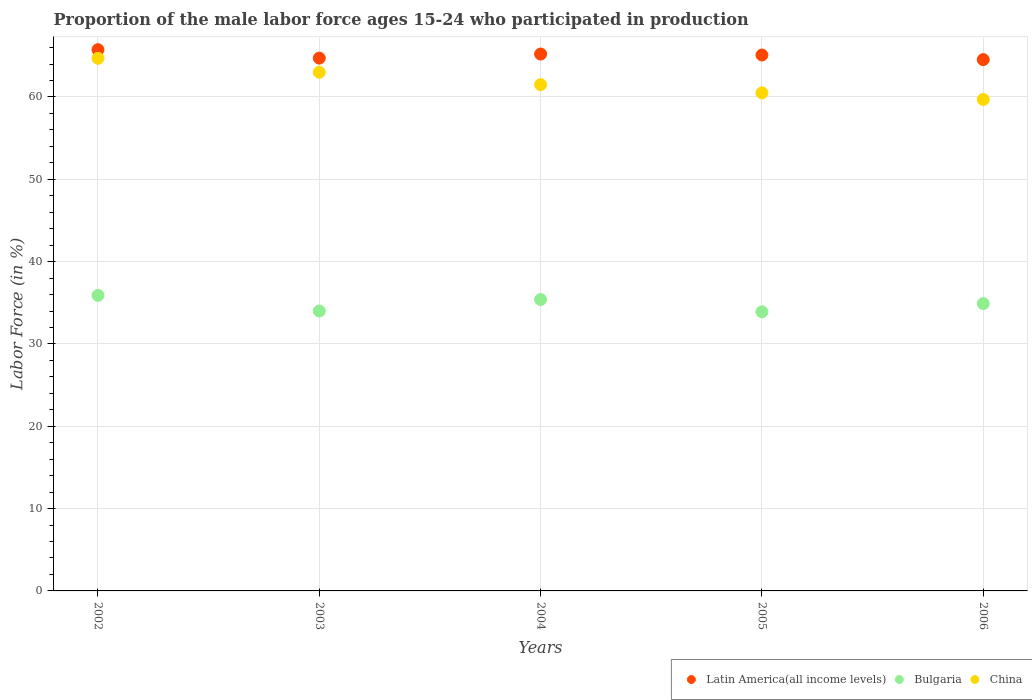What is the proportion of the male labor force who participated in production in Bulgaria in 2006?
Make the answer very short. 34.9. Across all years, what is the maximum proportion of the male labor force who participated in production in Latin America(all income levels)?
Keep it short and to the point. 65.75. Across all years, what is the minimum proportion of the male labor force who participated in production in China?
Offer a terse response. 59.7. What is the total proportion of the male labor force who participated in production in Latin America(all income levels) in the graph?
Keep it short and to the point. 325.32. What is the difference between the proportion of the male labor force who participated in production in Latin America(all income levels) in 2002 and that in 2004?
Give a very brief answer. 0.53. What is the difference between the proportion of the male labor force who participated in production in Latin America(all income levels) in 2006 and the proportion of the male labor force who participated in production in Bulgaria in 2002?
Provide a short and direct response. 28.64. What is the average proportion of the male labor force who participated in production in Latin America(all income levels) per year?
Ensure brevity in your answer.  65.06. In the year 2005, what is the difference between the proportion of the male labor force who participated in production in China and proportion of the male labor force who participated in production in Latin America(all income levels)?
Offer a very short reply. -4.6. In how many years, is the proportion of the male labor force who participated in production in Latin America(all income levels) greater than 38 %?
Give a very brief answer. 5. What is the ratio of the proportion of the male labor force who participated in production in China in 2005 to that in 2006?
Offer a very short reply. 1.01. Is the proportion of the male labor force who participated in production in Latin America(all income levels) in 2004 less than that in 2006?
Make the answer very short. No. Is the difference between the proportion of the male labor force who participated in production in China in 2004 and 2005 greater than the difference between the proportion of the male labor force who participated in production in Latin America(all income levels) in 2004 and 2005?
Your response must be concise. Yes. What is the difference between the highest and the second highest proportion of the male labor force who participated in production in China?
Offer a terse response. 1.7. What is the difference between the highest and the lowest proportion of the male labor force who participated in production in Latin America(all income levels)?
Give a very brief answer. 1.21. Does the proportion of the male labor force who participated in production in China monotonically increase over the years?
Your answer should be very brief. No. Is the proportion of the male labor force who participated in production in China strictly greater than the proportion of the male labor force who participated in production in Bulgaria over the years?
Provide a short and direct response. Yes. Is the proportion of the male labor force who participated in production in Bulgaria strictly less than the proportion of the male labor force who participated in production in China over the years?
Your answer should be compact. Yes. How many dotlines are there?
Make the answer very short. 3. Are the values on the major ticks of Y-axis written in scientific E-notation?
Offer a very short reply. No. Does the graph contain any zero values?
Keep it short and to the point. No. Does the graph contain grids?
Make the answer very short. Yes. Where does the legend appear in the graph?
Provide a short and direct response. Bottom right. How are the legend labels stacked?
Your answer should be compact. Horizontal. What is the title of the graph?
Ensure brevity in your answer.  Proportion of the male labor force ages 15-24 who participated in production. What is the label or title of the Y-axis?
Make the answer very short. Labor Force (in %). What is the Labor Force (in %) in Latin America(all income levels) in 2002?
Your response must be concise. 65.75. What is the Labor Force (in %) of Bulgaria in 2002?
Offer a very short reply. 35.9. What is the Labor Force (in %) of China in 2002?
Give a very brief answer. 64.7. What is the Labor Force (in %) in Latin America(all income levels) in 2003?
Give a very brief answer. 64.72. What is the Labor Force (in %) in Bulgaria in 2003?
Offer a very short reply. 34. What is the Labor Force (in %) in China in 2003?
Keep it short and to the point. 63. What is the Labor Force (in %) in Latin America(all income levels) in 2004?
Your response must be concise. 65.22. What is the Labor Force (in %) of Bulgaria in 2004?
Ensure brevity in your answer.  35.4. What is the Labor Force (in %) in China in 2004?
Ensure brevity in your answer.  61.5. What is the Labor Force (in %) in Latin America(all income levels) in 2005?
Provide a succinct answer. 65.1. What is the Labor Force (in %) of Bulgaria in 2005?
Offer a very short reply. 33.9. What is the Labor Force (in %) in China in 2005?
Your answer should be very brief. 60.5. What is the Labor Force (in %) of Latin America(all income levels) in 2006?
Your response must be concise. 64.54. What is the Labor Force (in %) in Bulgaria in 2006?
Your answer should be compact. 34.9. What is the Labor Force (in %) in China in 2006?
Your response must be concise. 59.7. Across all years, what is the maximum Labor Force (in %) in Latin America(all income levels)?
Make the answer very short. 65.75. Across all years, what is the maximum Labor Force (in %) in Bulgaria?
Your response must be concise. 35.9. Across all years, what is the maximum Labor Force (in %) in China?
Provide a succinct answer. 64.7. Across all years, what is the minimum Labor Force (in %) in Latin America(all income levels)?
Your answer should be compact. 64.54. Across all years, what is the minimum Labor Force (in %) in Bulgaria?
Your response must be concise. 33.9. Across all years, what is the minimum Labor Force (in %) of China?
Your response must be concise. 59.7. What is the total Labor Force (in %) of Latin America(all income levels) in the graph?
Offer a very short reply. 325.32. What is the total Labor Force (in %) in Bulgaria in the graph?
Offer a terse response. 174.1. What is the total Labor Force (in %) in China in the graph?
Make the answer very short. 309.4. What is the difference between the Labor Force (in %) in Latin America(all income levels) in 2002 and that in 2003?
Provide a succinct answer. 1.02. What is the difference between the Labor Force (in %) in Bulgaria in 2002 and that in 2003?
Your response must be concise. 1.9. What is the difference between the Labor Force (in %) in Latin America(all income levels) in 2002 and that in 2004?
Offer a very short reply. 0.53. What is the difference between the Labor Force (in %) of Bulgaria in 2002 and that in 2004?
Keep it short and to the point. 0.5. What is the difference between the Labor Force (in %) of China in 2002 and that in 2004?
Offer a very short reply. 3.2. What is the difference between the Labor Force (in %) of Latin America(all income levels) in 2002 and that in 2005?
Keep it short and to the point. 0.65. What is the difference between the Labor Force (in %) of Latin America(all income levels) in 2002 and that in 2006?
Your response must be concise. 1.21. What is the difference between the Labor Force (in %) in China in 2002 and that in 2006?
Ensure brevity in your answer.  5. What is the difference between the Labor Force (in %) of Latin America(all income levels) in 2003 and that in 2004?
Ensure brevity in your answer.  -0.49. What is the difference between the Labor Force (in %) in China in 2003 and that in 2004?
Ensure brevity in your answer.  1.5. What is the difference between the Labor Force (in %) in Latin America(all income levels) in 2003 and that in 2005?
Your answer should be compact. -0.38. What is the difference between the Labor Force (in %) in Latin America(all income levels) in 2003 and that in 2006?
Give a very brief answer. 0.18. What is the difference between the Labor Force (in %) in Latin America(all income levels) in 2004 and that in 2005?
Your answer should be very brief. 0.12. What is the difference between the Labor Force (in %) in China in 2004 and that in 2005?
Make the answer very short. 1. What is the difference between the Labor Force (in %) of Latin America(all income levels) in 2004 and that in 2006?
Give a very brief answer. 0.68. What is the difference between the Labor Force (in %) of Latin America(all income levels) in 2005 and that in 2006?
Provide a succinct answer. 0.56. What is the difference between the Labor Force (in %) of Bulgaria in 2005 and that in 2006?
Your answer should be compact. -1. What is the difference between the Labor Force (in %) of China in 2005 and that in 2006?
Give a very brief answer. 0.8. What is the difference between the Labor Force (in %) in Latin America(all income levels) in 2002 and the Labor Force (in %) in Bulgaria in 2003?
Your answer should be compact. 31.75. What is the difference between the Labor Force (in %) of Latin America(all income levels) in 2002 and the Labor Force (in %) of China in 2003?
Your answer should be very brief. 2.75. What is the difference between the Labor Force (in %) of Bulgaria in 2002 and the Labor Force (in %) of China in 2003?
Make the answer very short. -27.1. What is the difference between the Labor Force (in %) in Latin America(all income levels) in 2002 and the Labor Force (in %) in Bulgaria in 2004?
Offer a very short reply. 30.35. What is the difference between the Labor Force (in %) of Latin America(all income levels) in 2002 and the Labor Force (in %) of China in 2004?
Give a very brief answer. 4.25. What is the difference between the Labor Force (in %) of Bulgaria in 2002 and the Labor Force (in %) of China in 2004?
Offer a terse response. -25.6. What is the difference between the Labor Force (in %) of Latin America(all income levels) in 2002 and the Labor Force (in %) of Bulgaria in 2005?
Ensure brevity in your answer.  31.85. What is the difference between the Labor Force (in %) in Latin America(all income levels) in 2002 and the Labor Force (in %) in China in 2005?
Provide a short and direct response. 5.25. What is the difference between the Labor Force (in %) of Bulgaria in 2002 and the Labor Force (in %) of China in 2005?
Offer a terse response. -24.6. What is the difference between the Labor Force (in %) in Latin America(all income levels) in 2002 and the Labor Force (in %) in Bulgaria in 2006?
Make the answer very short. 30.85. What is the difference between the Labor Force (in %) in Latin America(all income levels) in 2002 and the Labor Force (in %) in China in 2006?
Offer a terse response. 6.05. What is the difference between the Labor Force (in %) in Bulgaria in 2002 and the Labor Force (in %) in China in 2006?
Keep it short and to the point. -23.8. What is the difference between the Labor Force (in %) in Latin America(all income levels) in 2003 and the Labor Force (in %) in Bulgaria in 2004?
Your answer should be very brief. 29.32. What is the difference between the Labor Force (in %) in Latin America(all income levels) in 2003 and the Labor Force (in %) in China in 2004?
Your answer should be compact. 3.22. What is the difference between the Labor Force (in %) of Bulgaria in 2003 and the Labor Force (in %) of China in 2004?
Your answer should be compact. -27.5. What is the difference between the Labor Force (in %) in Latin America(all income levels) in 2003 and the Labor Force (in %) in Bulgaria in 2005?
Offer a terse response. 30.82. What is the difference between the Labor Force (in %) in Latin America(all income levels) in 2003 and the Labor Force (in %) in China in 2005?
Provide a succinct answer. 4.22. What is the difference between the Labor Force (in %) of Bulgaria in 2003 and the Labor Force (in %) of China in 2005?
Your answer should be very brief. -26.5. What is the difference between the Labor Force (in %) of Latin America(all income levels) in 2003 and the Labor Force (in %) of Bulgaria in 2006?
Offer a very short reply. 29.82. What is the difference between the Labor Force (in %) in Latin America(all income levels) in 2003 and the Labor Force (in %) in China in 2006?
Your answer should be very brief. 5.02. What is the difference between the Labor Force (in %) of Bulgaria in 2003 and the Labor Force (in %) of China in 2006?
Keep it short and to the point. -25.7. What is the difference between the Labor Force (in %) in Latin America(all income levels) in 2004 and the Labor Force (in %) in Bulgaria in 2005?
Give a very brief answer. 31.32. What is the difference between the Labor Force (in %) of Latin America(all income levels) in 2004 and the Labor Force (in %) of China in 2005?
Your answer should be very brief. 4.72. What is the difference between the Labor Force (in %) of Bulgaria in 2004 and the Labor Force (in %) of China in 2005?
Make the answer very short. -25.1. What is the difference between the Labor Force (in %) of Latin America(all income levels) in 2004 and the Labor Force (in %) of Bulgaria in 2006?
Make the answer very short. 30.32. What is the difference between the Labor Force (in %) of Latin America(all income levels) in 2004 and the Labor Force (in %) of China in 2006?
Make the answer very short. 5.52. What is the difference between the Labor Force (in %) of Bulgaria in 2004 and the Labor Force (in %) of China in 2006?
Offer a very short reply. -24.3. What is the difference between the Labor Force (in %) in Latin America(all income levels) in 2005 and the Labor Force (in %) in Bulgaria in 2006?
Make the answer very short. 30.2. What is the difference between the Labor Force (in %) of Latin America(all income levels) in 2005 and the Labor Force (in %) of China in 2006?
Provide a short and direct response. 5.4. What is the difference between the Labor Force (in %) of Bulgaria in 2005 and the Labor Force (in %) of China in 2006?
Offer a terse response. -25.8. What is the average Labor Force (in %) in Latin America(all income levels) per year?
Ensure brevity in your answer.  65.06. What is the average Labor Force (in %) of Bulgaria per year?
Make the answer very short. 34.82. What is the average Labor Force (in %) in China per year?
Provide a succinct answer. 61.88. In the year 2002, what is the difference between the Labor Force (in %) of Latin America(all income levels) and Labor Force (in %) of Bulgaria?
Your answer should be compact. 29.85. In the year 2002, what is the difference between the Labor Force (in %) of Latin America(all income levels) and Labor Force (in %) of China?
Your answer should be very brief. 1.05. In the year 2002, what is the difference between the Labor Force (in %) of Bulgaria and Labor Force (in %) of China?
Provide a short and direct response. -28.8. In the year 2003, what is the difference between the Labor Force (in %) of Latin America(all income levels) and Labor Force (in %) of Bulgaria?
Provide a short and direct response. 30.72. In the year 2003, what is the difference between the Labor Force (in %) in Latin America(all income levels) and Labor Force (in %) in China?
Offer a terse response. 1.72. In the year 2003, what is the difference between the Labor Force (in %) in Bulgaria and Labor Force (in %) in China?
Your response must be concise. -29. In the year 2004, what is the difference between the Labor Force (in %) in Latin America(all income levels) and Labor Force (in %) in Bulgaria?
Ensure brevity in your answer.  29.82. In the year 2004, what is the difference between the Labor Force (in %) of Latin America(all income levels) and Labor Force (in %) of China?
Make the answer very short. 3.72. In the year 2004, what is the difference between the Labor Force (in %) in Bulgaria and Labor Force (in %) in China?
Make the answer very short. -26.1. In the year 2005, what is the difference between the Labor Force (in %) of Latin America(all income levels) and Labor Force (in %) of Bulgaria?
Keep it short and to the point. 31.2. In the year 2005, what is the difference between the Labor Force (in %) of Latin America(all income levels) and Labor Force (in %) of China?
Offer a very short reply. 4.6. In the year 2005, what is the difference between the Labor Force (in %) of Bulgaria and Labor Force (in %) of China?
Provide a short and direct response. -26.6. In the year 2006, what is the difference between the Labor Force (in %) of Latin America(all income levels) and Labor Force (in %) of Bulgaria?
Give a very brief answer. 29.64. In the year 2006, what is the difference between the Labor Force (in %) of Latin America(all income levels) and Labor Force (in %) of China?
Your answer should be compact. 4.84. In the year 2006, what is the difference between the Labor Force (in %) in Bulgaria and Labor Force (in %) in China?
Offer a very short reply. -24.8. What is the ratio of the Labor Force (in %) in Latin America(all income levels) in 2002 to that in 2003?
Your answer should be compact. 1.02. What is the ratio of the Labor Force (in %) of Bulgaria in 2002 to that in 2003?
Make the answer very short. 1.06. What is the ratio of the Labor Force (in %) in Latin America(all income levels) in 2002 to that in 2004?
Provide a succinct answer. 1.01. What is the ratio of the Labor Force (in %) of Bulgaria in 2002 to that in 2004?
Offer a very short reply. 1.01. What is the ratio of the Labor Force (in %) of China in 2002 to that in 2004?
Make the answer very short. 1.05. What is the ratio of the Labor Force (in %) in Latin America(all income levels) in 2002 to that in 2005?
Make the answer very short. 1.01. What is the ratio of the Labor Force (in %) in Bulgaria in 2002 to that in 2005?
Ensure brevity in your answer.  1.06. What is the ratio of the Labor Force (in %) in China in 2002 to that in 2005?
Offer a terse response. 1.07. What is the ratio of the Labor Force (in %) in Latin America(all income levels) in 2002 to that in 2006?
Offer a terse response. 1.02. What is the ratio of the Labor Force (in %) in Bulgaria in 2002 to that in 2006?
Offer a very short reply. 1.03. What is the ratio of the Labor Force (in %) in China in 2002 to that in 2006?
Your answer should be compact. 1.08. What is the ratio of the Labor Force (in %) of Latin America(all income levels) in 2003 to that in 2004?
Provide a short and direct response. 0.99. What is the ratio of the Labor Force (in %) of Bulgaria in 2003 to that in 2004?
Your answer should be very brief. 0.96. What is the ratio of the Labor Force (in %) in China in 2003 to that in 2004?
Give a very brief answer. 1.02. What is the ratio of the Labor Force (in %) in Bulgaria in 2003 to that in 2005?
Provide a short and direct response. 1. What is the ratio of the Labor Force (in %) in China in 2003 to that in 2005?
Your answer should be compact. 1.04. What is the ratio of the Labor Force (in %) in Bulgaria in 2003 to that in 2006?
Give a very brief answer. 0.97. What is the ratio of the Labor Force (in %) in China in 2003 to that in 2006?
Your answer should be compact. 1.06. What is the ratio of the Labor Force (in %) in Bulgaria in 2004 to that in 2005?
Make the answer very short. 1.04. What is the ratio of the Labor Force (in %) of China in 2004 to that in 2005?
Ensure brevity in your answer.  1.02. What is the ratio of the Labor Force (in %) of Latin America(all income levels) in 2004 to that in 2006?
Provide a short and direct response. 1.01. What is the ratio of the Labor Force (in %) in Bulgaria in 2004 to that in 2006?
Provide a succinct answer. 1.01. What is the ratio of the Labor Force (in %) of China in 2004 to that in 2006?
Make the answer very short. 1.03. What is the ratio of the Labor Force (in %) in Latin America(all income levels) in 2005 to that in 2006?
Offer a terse response. 1.01. What is the ratio of the Labor Force (in %) of Bulgaria in 2005 to that in 2006?
Provide a short and direct response. 0.97. What is the ratio of the Labor Force (in %) of China in 2005 to that in 2006?
Your answer should be very brief. 1.01. What is the difference between the highest and the second highest Labor Force (in %) in Latin America(all income levels)?
Provide a succinct answer. 0.53. What is the difference between the highest and the second highest Labor Force (in %) of Bulgaria?
Provide a succinct answer. 0.5. What is the difference between the highest and the second highest Labor Force (in %) in China?
Offer a very short reply. 1.7. What is the difference between the highest and the lowest Labor Force (in %) in Latin America(all income levels)?
Make the answer very short. 1.21. 